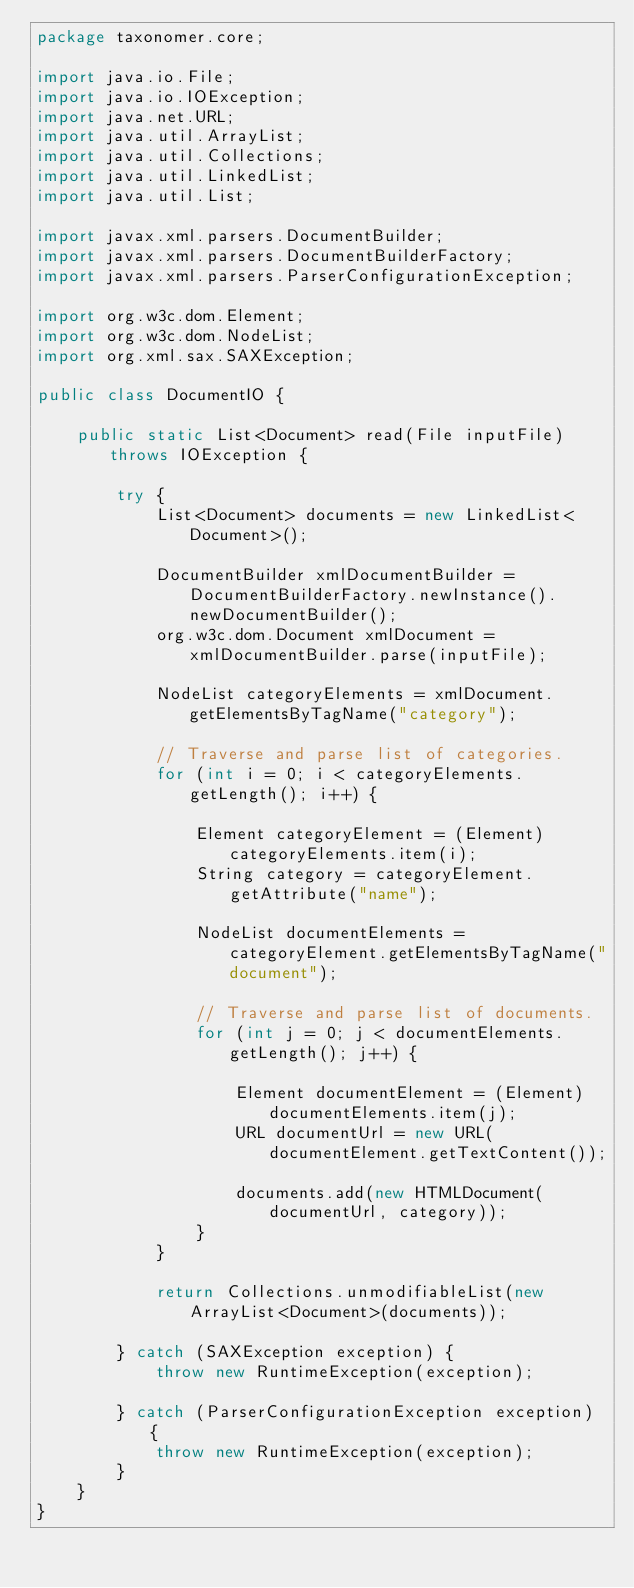Convert code to text. <code><loc_0><loc_0><loc_500><loc_500><_Java_>package taxonomer.core;

import java.io.File;
import java.io.IOException;
import java.net.URL;
import java.util.ArrayList;
import java.util.Collections;
import java.util.LinkedList;
import java.util.List;

import javax.xml.parsers.DocumentBuilder;
import javax.xml.parsers.DocumentBuilderFactory;
import javax.xml.parsers.ParserConfigurationException;

import org.w3c.dom.Element;
import org.w3c.dom.NodeList;
import org.xml.sax.SAXException;

public class DocumentIO {
    
    public static List<Document> read(File inputFile) throws IOException {
        
        try {
            List<Document> documents = new LinkedList<Document>();

            DocumentBuilder xmlDocumentBuilder = DocumentBuilderFactory.newInstance().newDocumentBuilder();
            org.w3c.dom.Document xmlDocument = xmlDocumentBuilder.parse(inputFile);

            NodeList categoryElements = xmlDocument.getElementsByTagName("category");

            // Traverse and parse list of categories.
            for (int i = 0; i < categoryElements.getLength(); i++) {

                Element categoryElement = (Element) categoryElements.item(i);
                String category = categoryElement.getAttribute("name");

                NodeList documentElements = categoryElement.getElementsByTagName("document");

                // Traverse and parse list of documents.
                for (int j = 0; j < documentElements.getLength(); j++) {

                    Element documentElement = (Element) documentElements.item(j);
                    URL documentUrl = new URL(documentElement.getTextContent());

                    documents.add(new HTMLDocument(documentUrl, category));
                }
            }

            return Collections.unmodifiableList(new ArrayList<Document>(documents));

        } catch (SAXException exception) {
            throw new RuntimeException(exception);

        } catch (ParserConfigurationException exception) {
            throw new RuntimeException(exception);
        } 
    }
}
</code> 